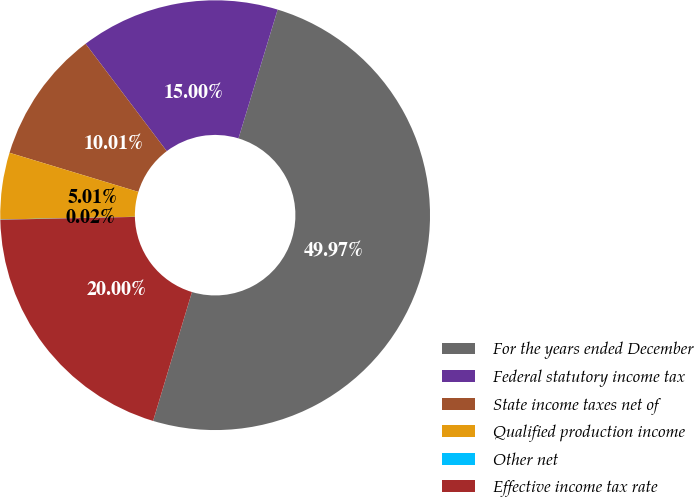Convert chart to OTSL. <chart><loc_0><loc_0><loc_500><loc_500><pie_chart><fcel>For the years ended December<fcel>Federal statutory income tax<fcel>State income taxes net of<fcel>Qualified production income<fcel>Other net<fcel>Effective income tax rate<nl><fcel>49.97%<fcel>15.0%<fcel>10.01%<fcel>5.01%<fcel>0.02%<fcel>20.0%<nl></chart> 